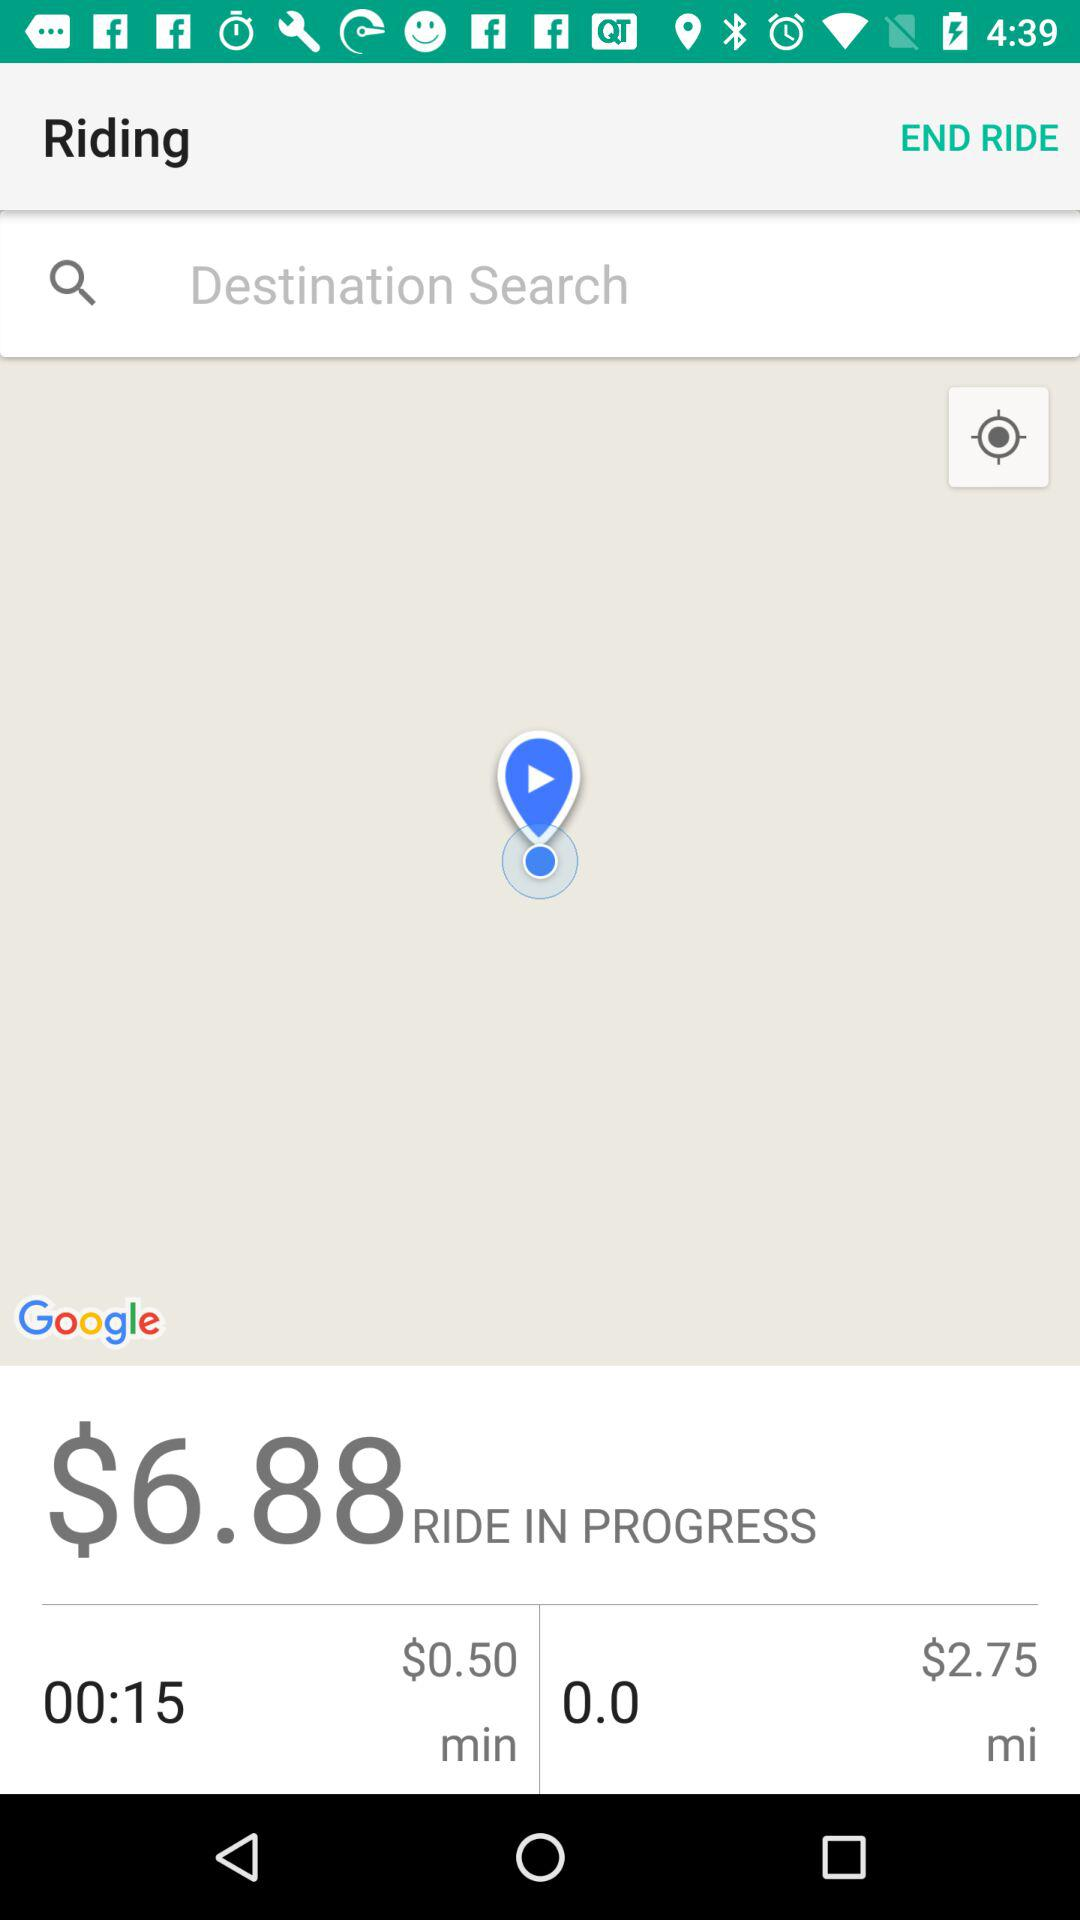Where is the user destined?
When the provided information is insufficient, respond with <no answer>. <no answer> 